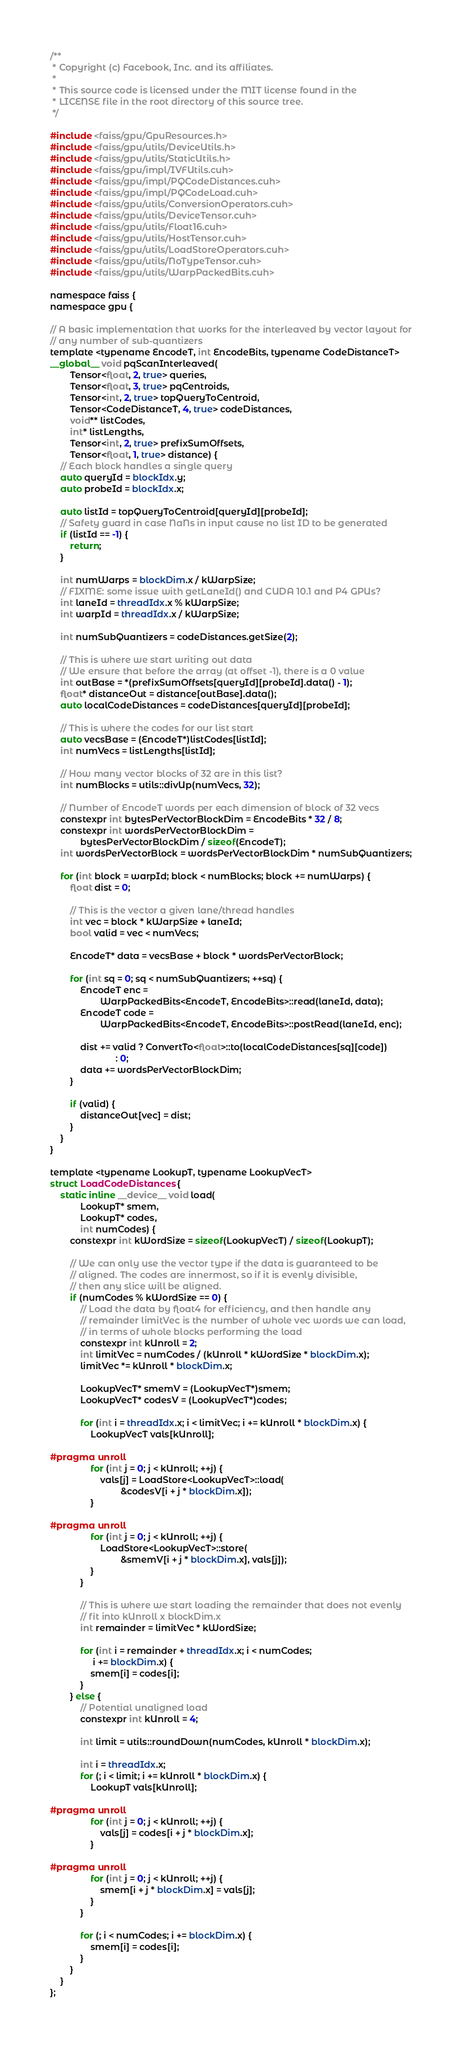<code> <loc_0><loc_0><loc_500><loc_500><_Cuda_>/**
 * Copyright (c) Facebook, Inc. and its affiliates.
 *
 * This source code is licensed under the MIT license found in the
 * LICENSE file in the root directory of this source tree.
 */

#include <faiss/gpu/GpuResources.h>
#include <faiss/gpu/utils/DeviceUtils.h>
#include <faiss/gpu/utils/StaticUtils.h>
#include <faiss/gpu/impl/IVFUtils.cuh>
#include <faiss/gpu/impl/PQCodeDistances.cuh>
#include <faiss/gpu/impl/PQCodeLoad.cuh>
#include <faiss/gpu/utils/ConversionOperators.cuh>
#include <faiss/gpu/utils/DeviceTensor.cuh>
#include <faiss/gpu/utils/Float16.cuh>
#include <faiss/gpu/utils/HostTensor.cuh>
#include <faiss/gpu/utils/LoadStoreOperators.cuh>
#include <faiss/gpu/utils/NoTypeTensor.cuh>
#include <faiss/gpu/utils/WarpPackedBits.cuh>

namespace faiss {
namespace gpu {

// A basic implementation that works for the interleaved by vector layout for
// any number of sub-quantizers
template <typename EncodeT, int EncodeBits, typename CodeDistanceT>
__global__ void pqScanInterleaved(
        Tensor<float, 2, true> queries,
        Tensor<float, 3, true> pqCentroids,
        Tensor<int, 2, true> topQueryToCentroid,
        Tensor<CodeDistanceT, 4, true> codeDistances,
        void** listCodes,
        int* listLengths,
        Tensor<int, 2, true> prefixSumOffsets,
        Tensor<float, 1, true> distance) {
    // Each block handles a single query
    auto queryId = blockIdx.y;
    auto probeId = blockIdx.x;

    auto listId = topQueryToCentroid[queryId][probeId];
    // Safety guard in case NaNs in input cause no list ID to be generated
    if (listId == -1) {
        return;
    }

    int numWarps = blockDim.x / kWarpSize;
    // FIXME: some issue with getLaneId() and CUDA 10.1 and P4 GPUs?
    int laneId = threadIdx.x % kWarpSize;
    int warpId = threadIdx.x / kWarpSize;

    int numSubQuantizers = codeDistances.getSize(2);

    // This is where we start writing out data
    // We ensure that before the array (at offset -1), there is a 0 value
    int outBase = *(prefixSumOffsets[queryId][probeId].data() - 1);
    float* distanceOut = distance[outBase].data();
    auto localCodeDistances = codeDistances[queryId][probeId];

    // This is where the codes for our list start
    auto vecsBase = (EncodeT*)listCodes[listId];
    int numVecs = listLengths[listId];

    // How many vector blocks of 32 are in this list?
    int numBlocks = utils::divUp(numVecs, 32);

    // Number of EncodeT words per each dimension of block of 32 vecs
    constexpr int bytesPerVectorBlockDim = EncodeBits * 32 / 8;
    constexpr int wordsPerVectorBlockDim =
            bytesPerVectorBlockDim / sizeof(EncodeT);
    int wordsPerVectorBlock = wordsPerVectorBlockDim * numSubQuantizers;

    for (int block = warpId; block < numBlocks; block += numWarps) {
        float dist = 0;

        // This is the vector a given lane/thread handles
        int vec = block * kWarpSize + laneId;
        bool valid = vec < numVecs;

        EncodeT* data = vecsBase + block * wordsPerVectorBlock;

        for (int sq = 0; sq < numSubQuantizers; ++sq) {
            EncodeT enc =
                    WarpPackedBits<EncodeT, EncodeBits>::read(laneId, data);
            EncodeT code =
                    WarpPackedBits<EncodeT, EncodeBits>::postRead(laneId, enc);

            dist += valid ? ConvertTo<float>::to(localCodeDistances[sq][code])
                          : 0;
            data += wordsPerVectorBlockDim;
        }

        if (valid) {
            distanceOut[vec] = dist;
        }
    }
}

template <typename LookupT, typename LookupVecT>
struct LoadCodeDistances {
    static inline __device__ void load(
            LookupT* smem,
            LookupT* codes,
            int numCodes) {
        constexpr int kWordSize = sizeof(LookupVecT) / sizeof(LookupT);

        // We can only use the vector type if the data is guaranteed to be
        // aligned. The codes are innermost, so if it is evenly divisible,
        // then any slice will be aligned.
        if (numCodes % kWordSize == 0) {
            // Load the data by float4 for efficiency, and then handle any
            // remainder limitVec is the number of whole vec words we can load,
            // in terms of whole blocks performing the load
            constexpr int kUnroll = 2;
            int limitVec = numCodes / (kUnroll * kWordSize * blockDim.x);
            limitVec *= kUnroll * blockDim.x;

            LookupVecT* smemV = (LookupVecT*)smem;
            LookupVecT* codesV = (LookupVecT*)codes;

            for (int i = threadIdx.x; i < limitVec; i += kUnroll * blockDim.x) {
                LookupVecT vals[kUnroll];

#pragma unroll
                for (int j = 0; j < kUnroll; ++j) {
                    vals[j] = LoadStore<LookupVecT>::load(
                            &codesV[i + j * blockDim.x]);
                }

#pragma unroll
                for (int j = 0; j < kUnroll; ++j) {
                    LoadStore<LookupVecT>::store(
                            &smemV[i + j * blockDim.x], vals[j]);
                }
            }

            // This is where we start loading the remainder that does not evenly
            // fit into kUnroll x blockDim.x
            int remainder = limitVec * kWordSize;

            for (int i = remainder + threadIdx.x; i < numCodes;
                 i += blockDim.x) {
                smem[i] = codes[i];
            }
        } else {
            // Potential unaligned load
            constexpr int kUnroll = 4;

            int limit = utils::roundDown(numCodes, kUnroll * blockDim.x);

            int i = threadIdx.x;
            for (; i < limit; i += kUnroll * blockDim.x) {
                LookupT vals[kUnroll];

#pragma unroll
                for (int j = 0; j < kUnroll; ++j) {
                    vals[j] = codes[i + j * blockDim.x];
                }

#pragma unroll
                for (int j = 0; j < kUnroll; ++j) {
                    smem[i + j * blockDim.x] = vals[j];
                }
            }

            for (; i < numCodes; i += blockDim.x) {
                smem[i] = codes[i];
            }
        }
    }
};
</code> 